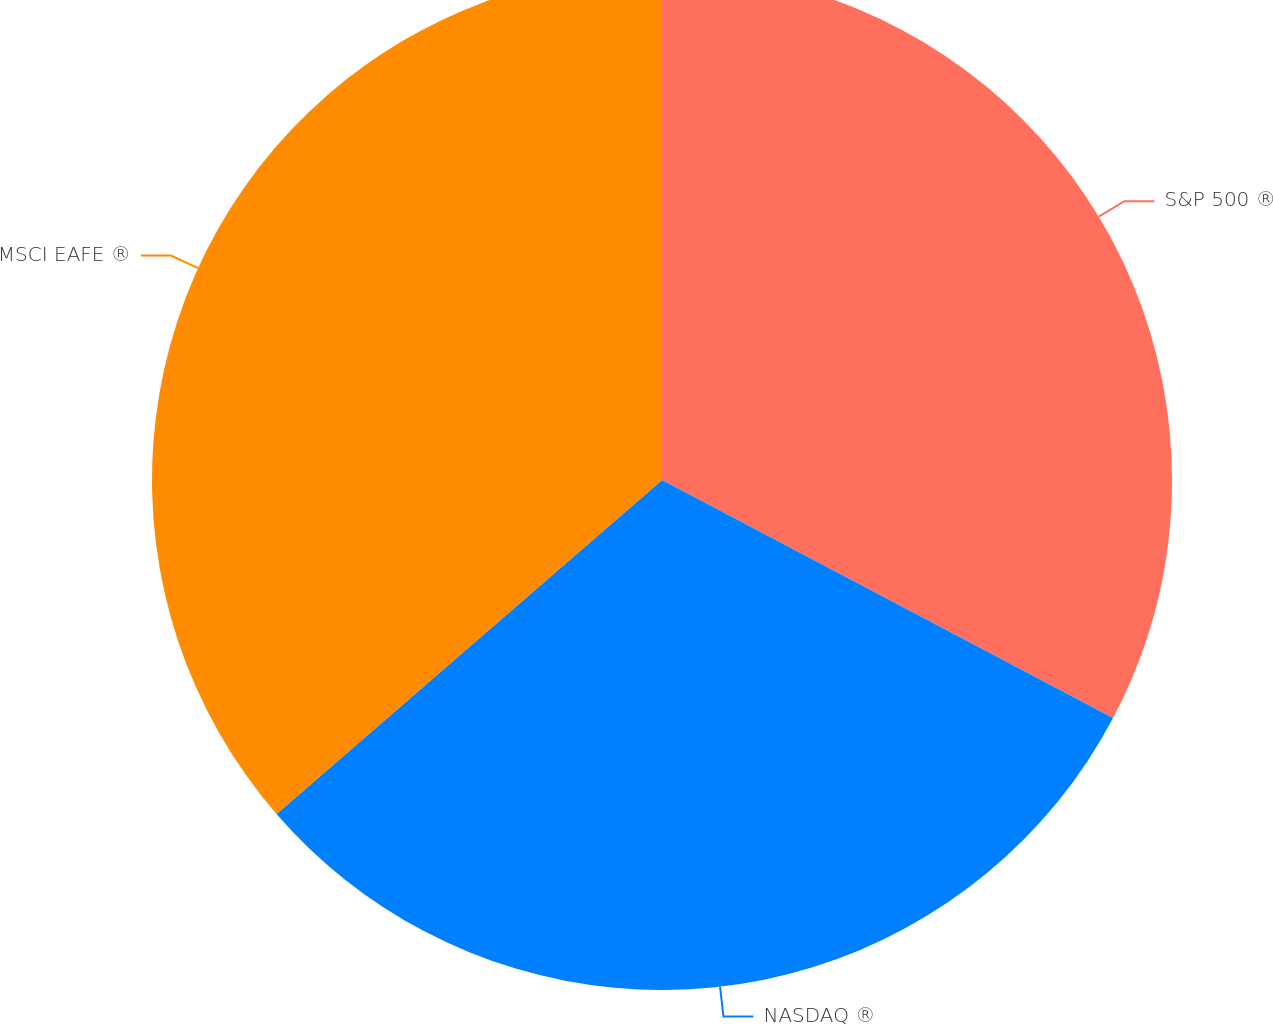Convert chart to OTSL. <chart><loc_0><loc_0><loc_500><loc_500><pie_chart><fcel>S&P 500 ®<fcel>NASDAQ ®<fcel>MSCI EAFE ®<nl><fcel>32.73%<fcel>30.91%<fcel>36.36%<nl></chart> 